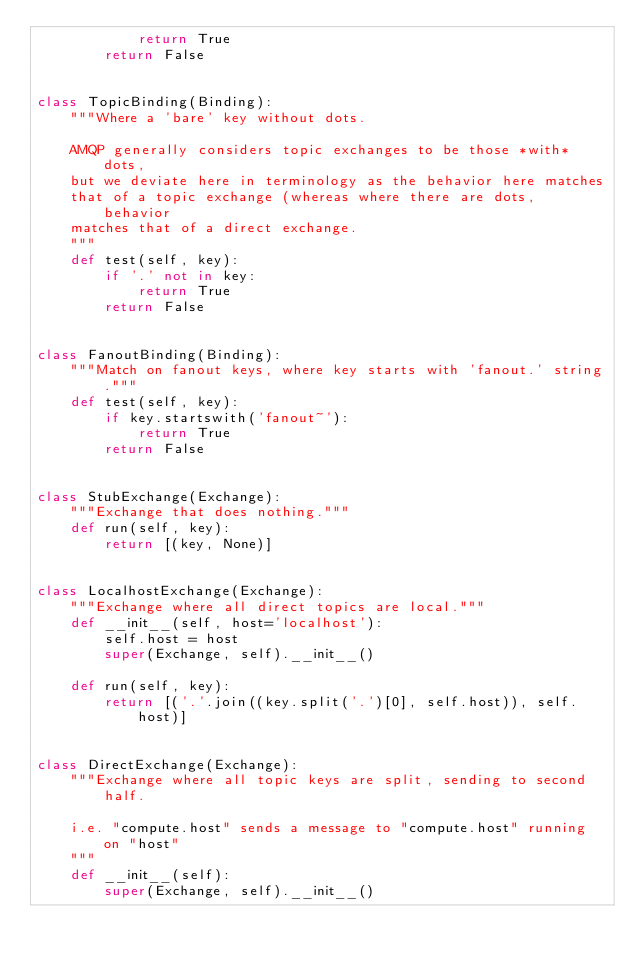Convert code to text. <code><loc_0><loc_0><loc_500><loc_500><_Python_>            return True
        return False


class TopicBinding(Binding):
    """Where a 'bare' key without dots.

    AMQP generally considers topic exchanges to be those *with* dots,
    but we deviate here in terminology as the behavior here matches
    that of a topic exchange (whereas where there are dots, behavior
    matches that of a direct exchange.
    """
    def test(self, key):
        if '.' not in key:
            return True
        return False


class FanoutBinding(Binding):
    """Match on fanout keys, where key starts with 'fanout.' string."""
    def test(self, key):
        if key.startswith('fanout~'):
            return True
        return False


class StubExchange(Exchange):
    """Exchange that does nothing."""
    def run(self, key):
        return [(key, None)]


class LocalhostExchange(Exchange):
    """Exchange where all direct topics are local."""
    def __init__(self, host='localhost'):
        self.host = host
        super(Exchange, self).__init__()

    def run(self, key):
        return [('.'.join((key.split('.')[0], self.host)), self.host)]


class DirectExchange(Exchange):
    """Exchange where all topic keys are split, sending to second half.

    i.e. "compute.host" sends a message to "compute.host" running on "host"
    """
    def __init__(self):
        super(Exchange, self).__init__()
</code> 